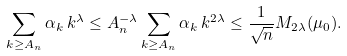Convert formula to latex. <formula><loc_0><loc_0><loc_500><loc_500>\sum _ { k \geq A _ { n } } \alpha _ { k } \, k ^ { \lambda } \leq A _ { n } ^ { - \lambda } \sum _ { k \geq A _ { n } } \alpha _ { k } \, k ^ { 2 \lambda } \leq \frac { 1 } { \sqrt { n } } M _ { 2 \lambda } ( \mu _ { 0 } ) .</formula> 